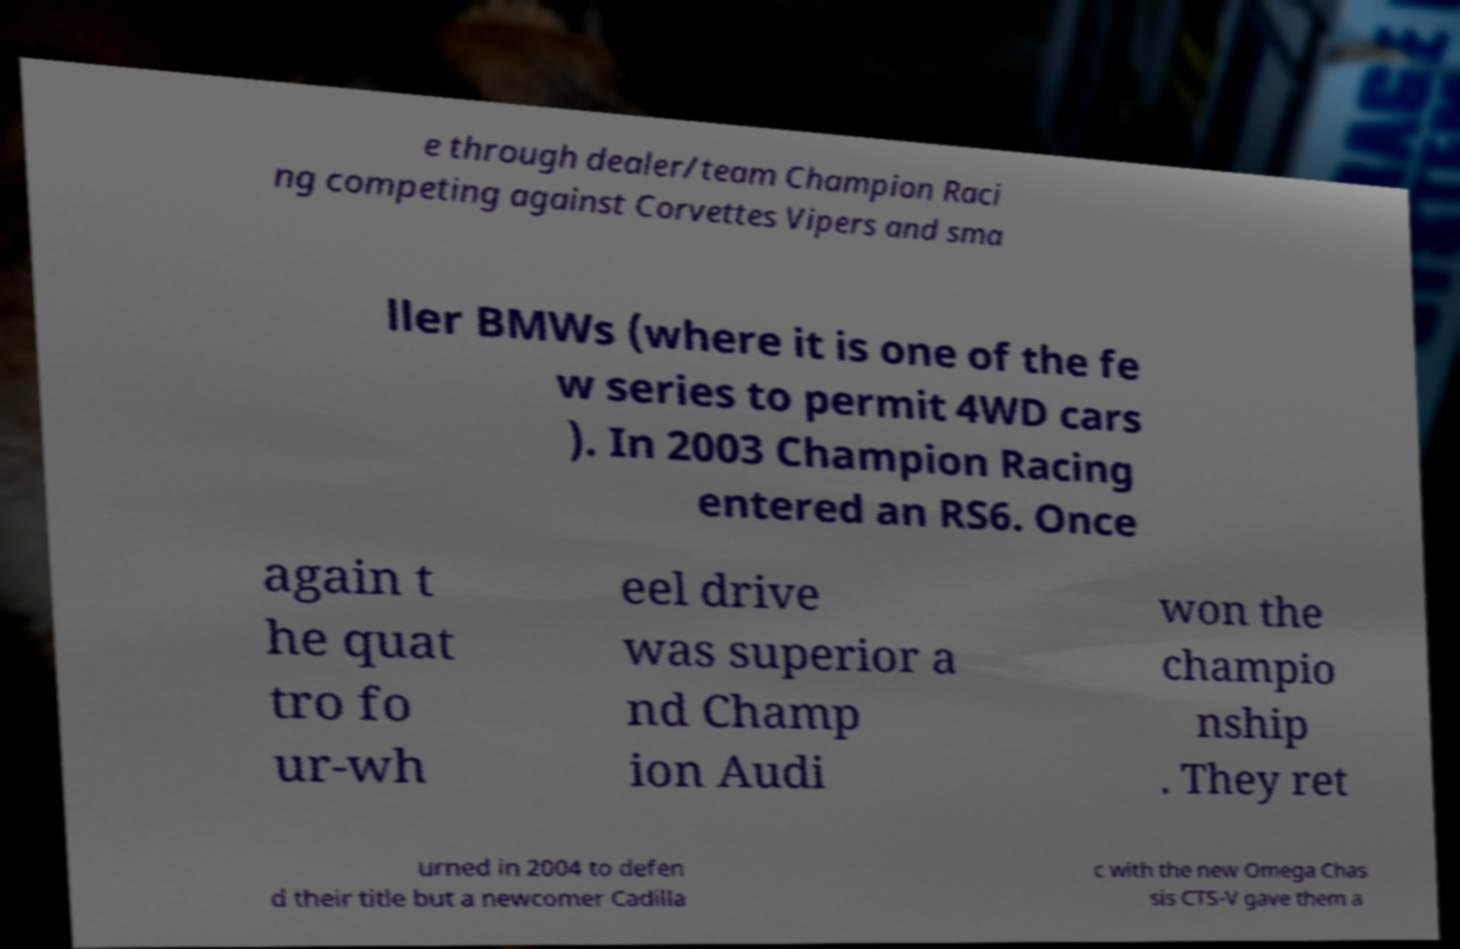What messages or text are displayed in this image? I need them in a readable, typed format. e through dealer/team Champion Raci ng competing against Corvettes Vipers and sma ller BMWs (where it is one of the fe w series to permit 4WD cars ). In 2003 Champion Racing entered an RS6. Once again t he quat tro fo ur-wh eel drive was superior a nd Champ ion Audi won the champio nship . They ret urned in 2004 to defen d their title but a newcomer Cadilla c with the new Omega Chas sis CTS-V gave them a 